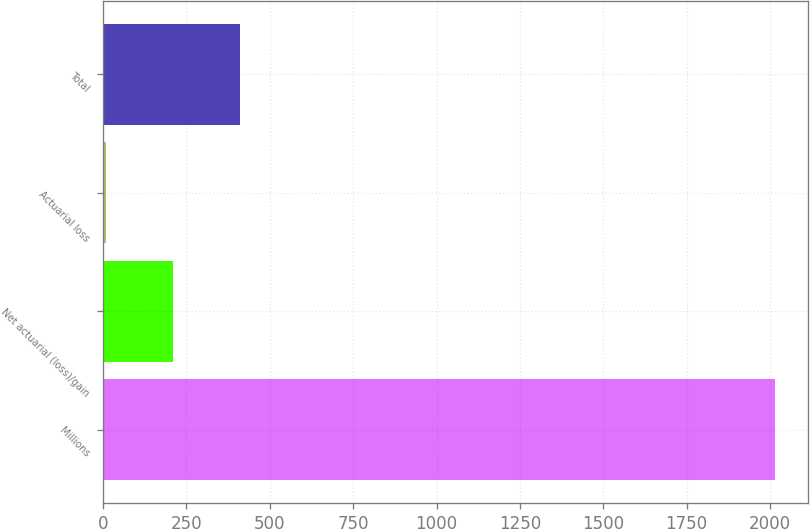Convert chart to OTSL. <chart><loc_0><loc_0><loc_500><loc_500><bar_chart><fcel>Millions<fcel>Net actuarial (loss)/gain<fcel>Actuarial loss<fcel>Total<nl><fcel>2014<fcel>210.4<fcel>10<fcel>410.8<nl></chart> 